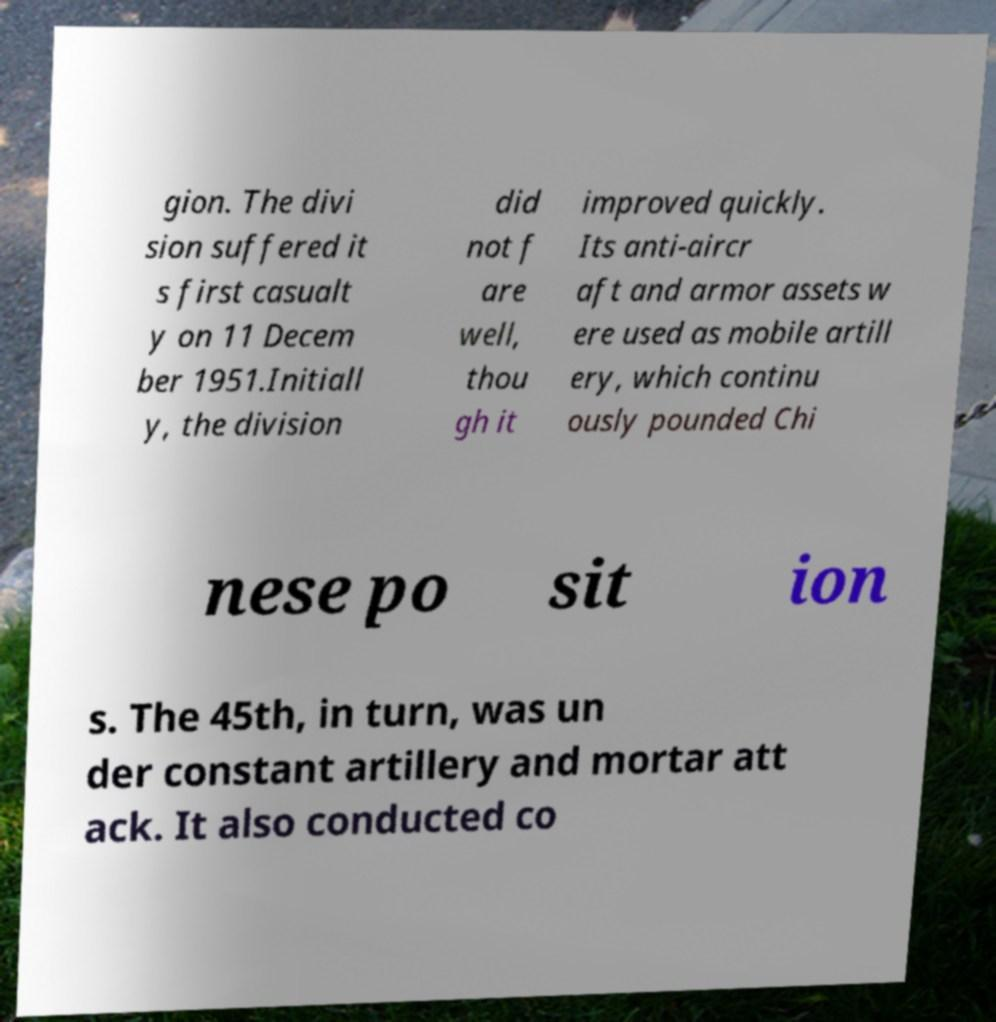Could you assist in decoding the text presented in this image and type it out clearly? gion. The divi sion suffered it s first casualt y on 11 Decem ber 1951.Initiall y, the division did not f are well, thou gh it improved quickly. Its anti-aircr aft and armor assets w ere used as mobile artill ery, which continu ously pounded Chi nese po sit ion s. The 45th, in turn, was un der constant artillery and mortar att ack. It also conducted co 